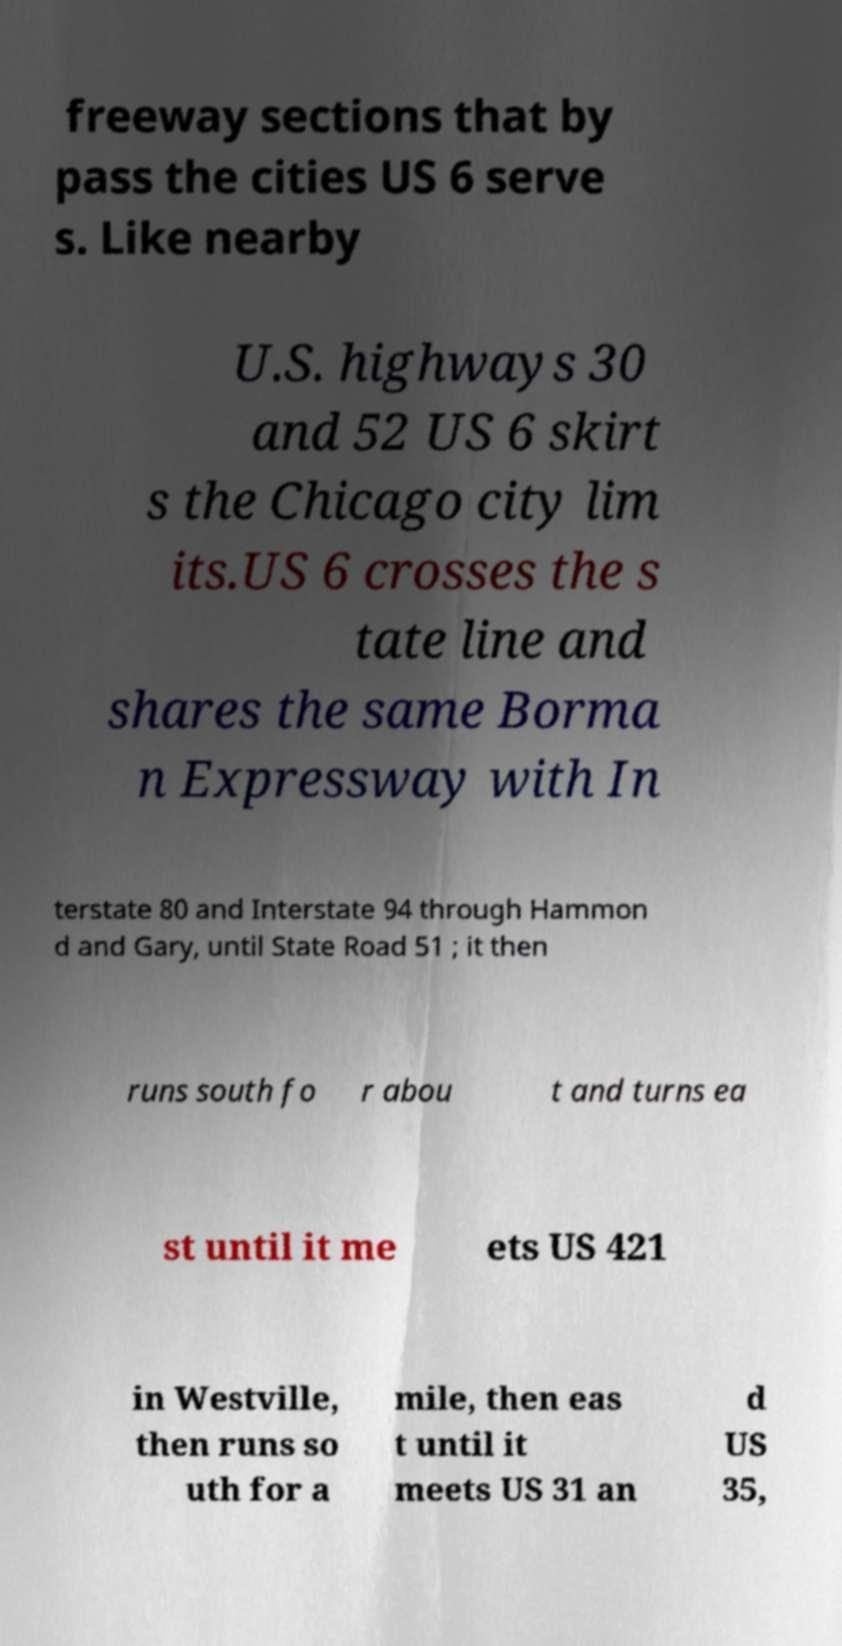Please read and relay the text visible in this image. What does it say? freeway sections that by pass the cities US 6 serve s. Like nearby U.S. highways 30 and 52 US 6 skirt s the Chicago city lim its.US 6 crosses the s tate line and shares the same Borma n Expressway with In terstate 80 and Interstate 94 through Hammon d and Gary, until State Road 51 ; it then runs south fo r abou t and turns ea st until it me ets US 421 in Westville, then runs so uth for a mile, then eas t until it meets US 31 an d US 35, 